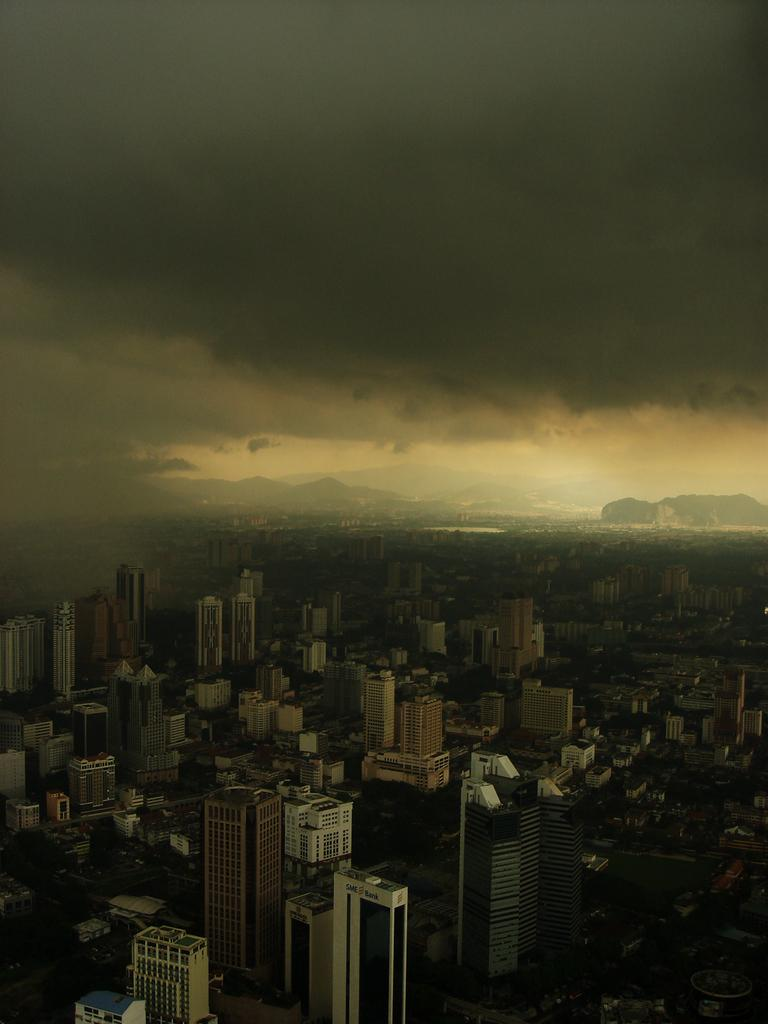What type of structures can be seen in the image? There are buildings in the image. What other natural elements are present in the image? There are trees and hills in the image. What is visible at the top of the image? The sky is visible at the top of the image. How would you describe the sky in the image? The sky appears to be cloudy. What type of sheet is covering the trees in the image? There is no sheet covering the trees in the image; it only shows trees, buildings, hills, and a cloudy sky. 